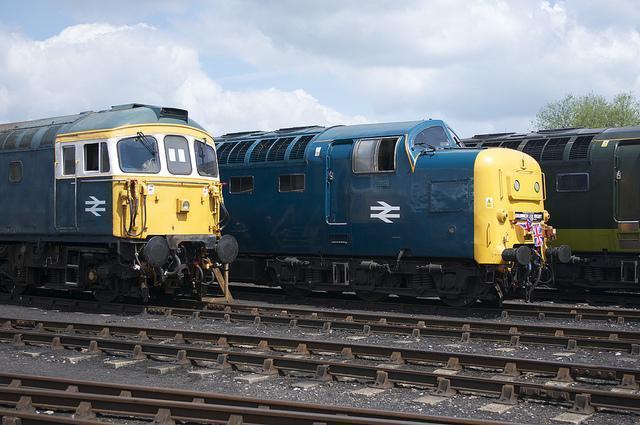How many trains are visible?
Give a very brief answer. 3. How many trains are in the picture?
Give a very brief answer. 3. 